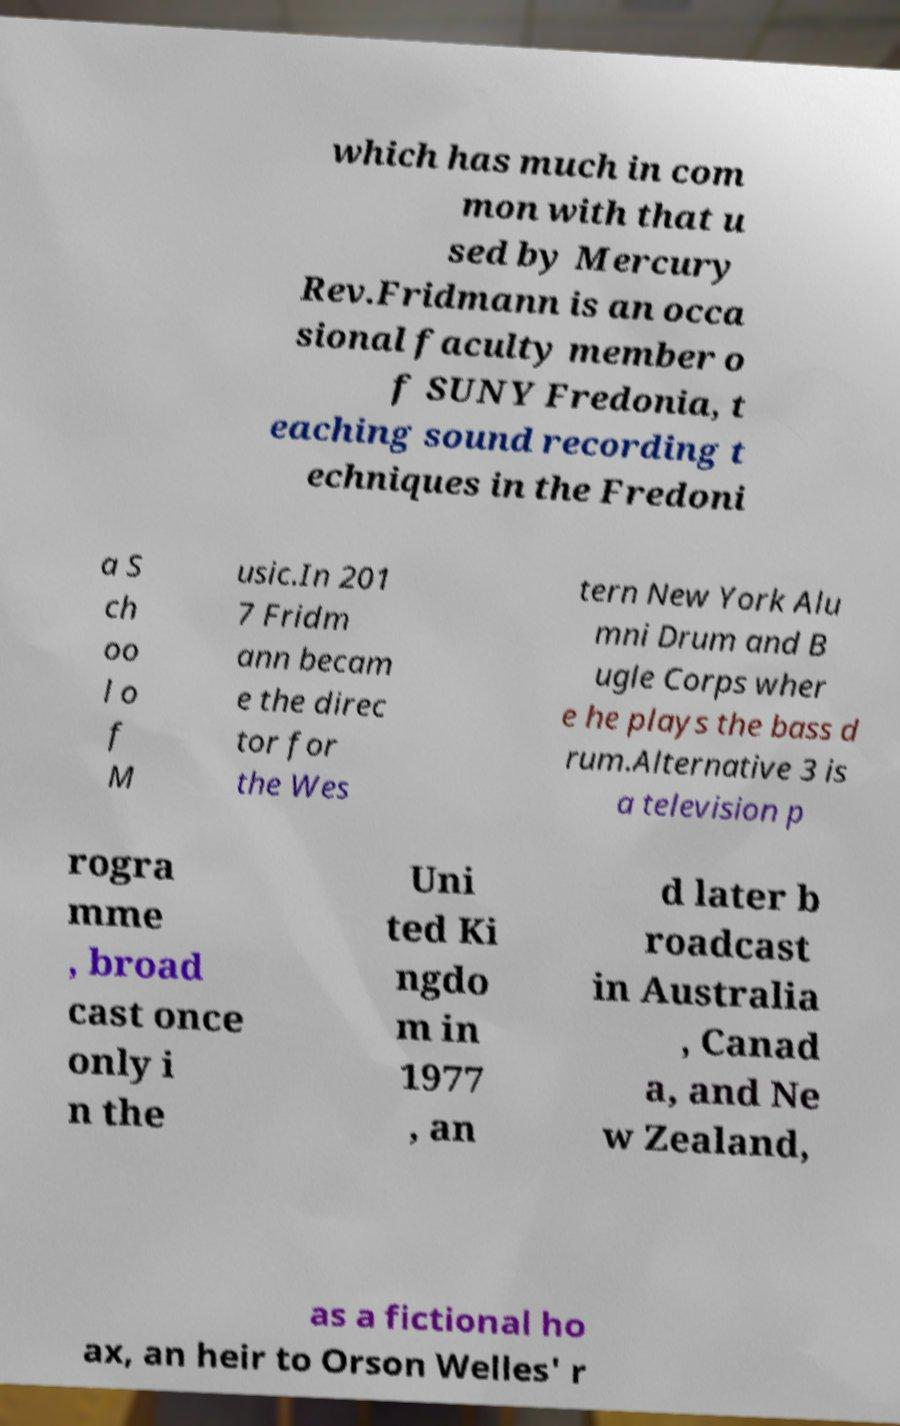Can you accurately transcribe the text from the provided image for me? which has much in com mon with that u sed by Mercury Rev.Fridmann is an occa sional faculty member o f SUNY Fredonia, t eaching sound recording t echniques in the Fredoni a S ch oo l o f M usic.In 201 7 Fridm ann becam e the direc tor for the Wes tern New York Alu mni Drum and B ugle Corps wher e he plays the bass d rum.Alternative 3 is a television p rogra mme , broad cast once only i n the Uni ted Ki ngdo m in 1977 , an d later b roadcast in Australia , Canad a, and Ne w Zealand, as a fictional ho ax, an heir to Orson Welles' r 